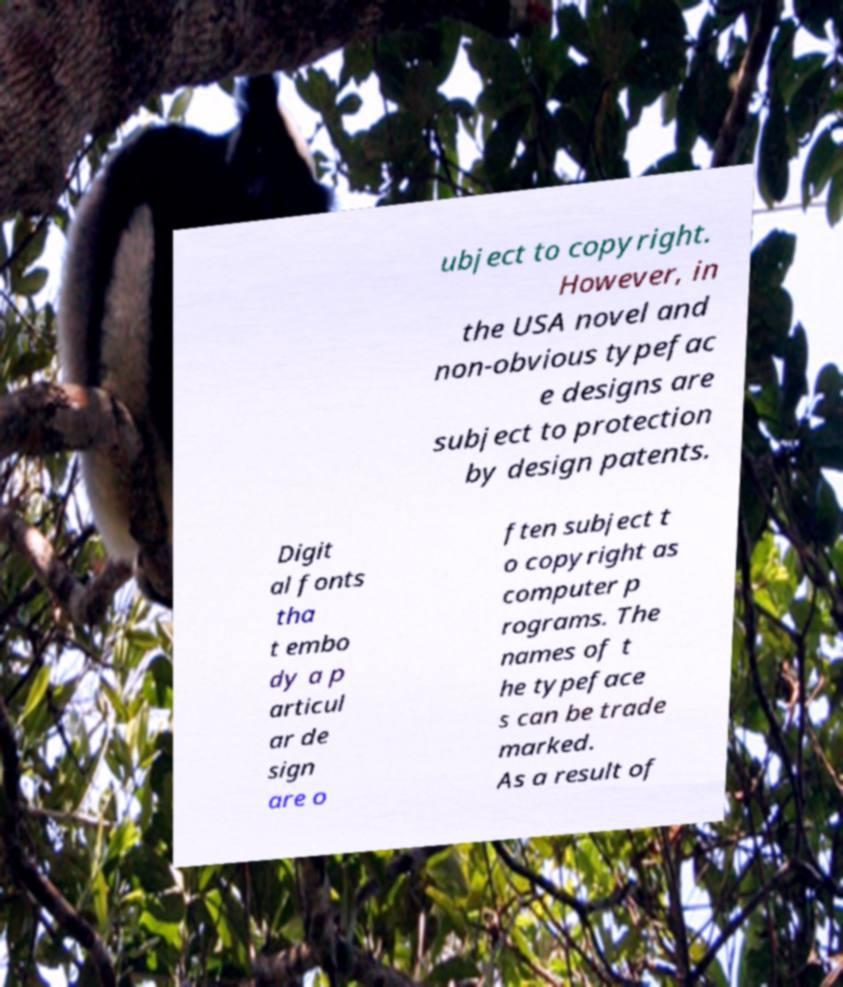For documentation purposes, I need the text within this image transcribed. Could you provide that? ubject to copyright. However, in the USA novel and non-obvious typefac e designs are subject to protection by design patents. Digit al fonts tha t embo dy a p articul ar de sign are o ften subject t o copyright as computer p rograms. The names of t he typeface s can be trade marked. As a result of 